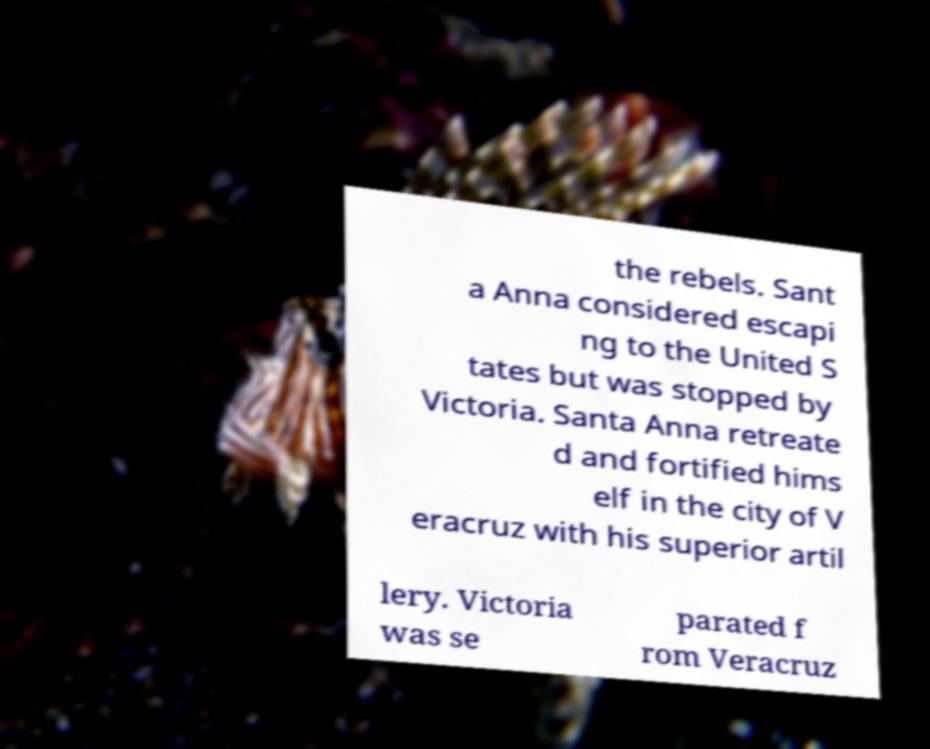Could you extract and type out the text from this image? the rebels. Sant a Anna considered escapi ng to the United S tates but was stopped by Victoria. Santa Anna retreate d and fortified hims elf in the city of V eracruz with his superior artil lery. Victoria was se parated f rom Veracruz 